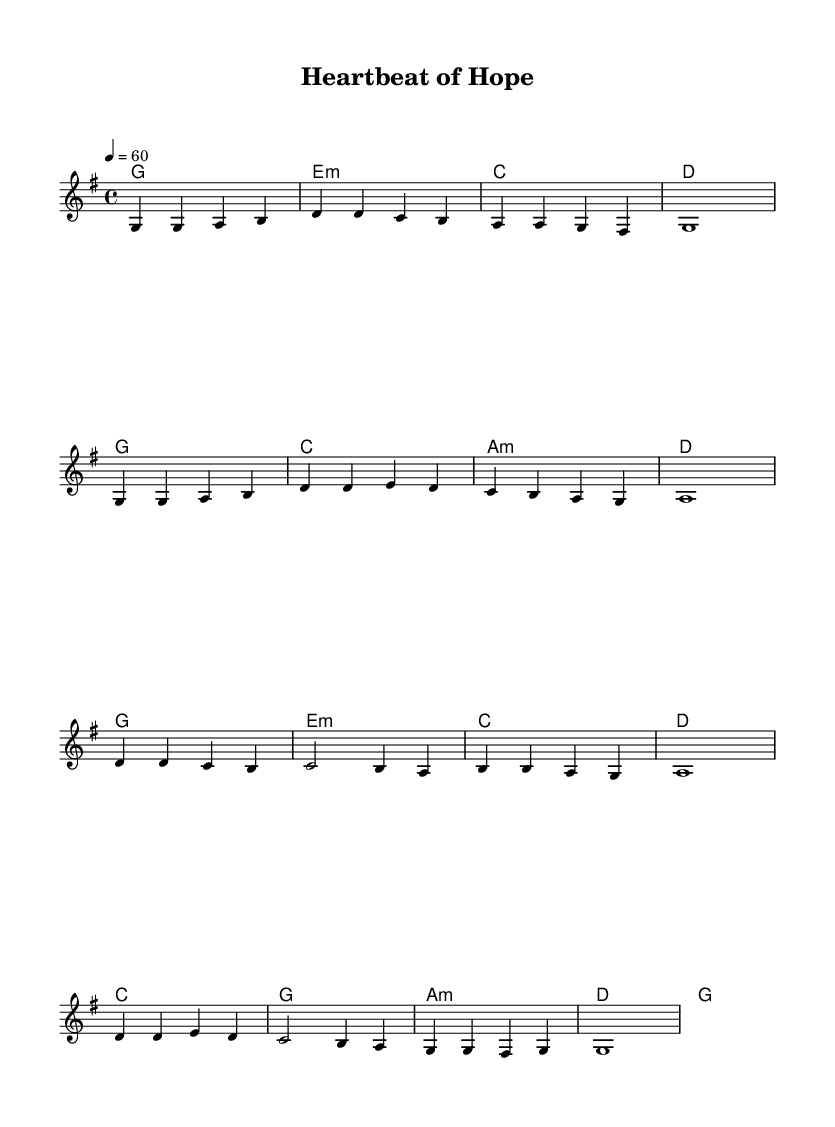What is the key signature of this music? The key signature at the beginning of the piece shows two sharps, indicating that the music is in the key of D major.
Answer: D major What is the time signature of this music? The time signature, located right after the key signature, is 4/4, which means there are four beats in each measure and the quarter note gets one beat.
Answer: 4/4 What is the tempo marking for the piece? The tempo marking is indicated at the beginning with a quarter note equals 60, meaning the piece is set to be played at 60 beats per minute.
Answer: 60 How many measures are in the verse section? By counting the measures in the melody part provided for the verse, it appears there are 8 measures.
Answer: 8 What is the first chord of the piece? The first chord is indicated at the beginning of the score, labeled as G major, which corresponds to the first measure of the harmonies.
Answer: G Which lyrical section supports the chorus? The chorus section in the melody is paired with the harmonic progression starting with D major, marking the shift from the verse to the chorus.
Answer: D Name the last chord of the chorus. The score indicates that the final chord in the chorus is G major, as shown in the last measure of the harmonic structure.
Answer: G 